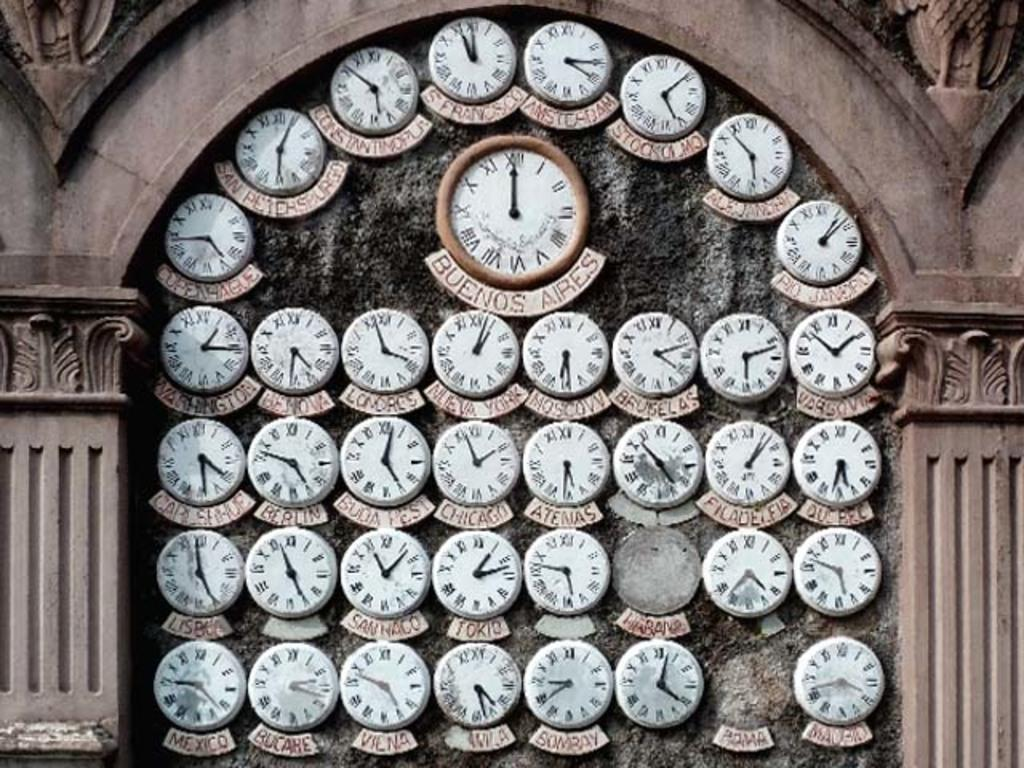<image>
Share a concise interpretation of the image provided. A number of clock faces, one of which has the word Bombay under it. 